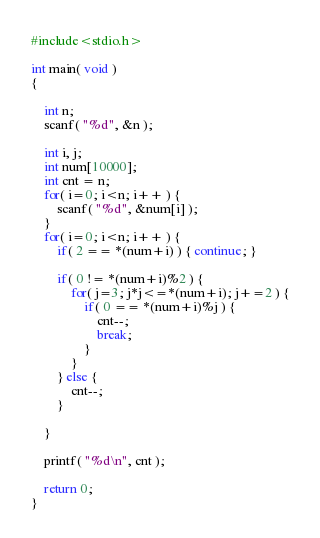Convert code to text. <code><loc_0><loc_0><loc_500><loc_500><_C_>#include<stdio.h>
 
int main( void ) 
{
 
    int n;
    scanf( "%d", &n );
    
    int i, j;
    int num[10000]; 
    int cnt = n;
    for( i=0; i<n; i++ ) {
        scanf( "%d", &num[i] );
    }
    for( i=0; i<n; i++ ) {    
        if( 2 == *(num+i) ) { continue; }
        
        if( 0 != *(num+i)%2 ) {
            for( j=3; j*j<=*(num+i); j+=2 ) {
                if( 0 == *(num+i)%j ) {
                    cnt--;
                    break;
                }
            }
        } else {
            cnt--;
        }
        
    }
     
    printf( "%d\n", cnt );
    
    return 0;
}</code> 